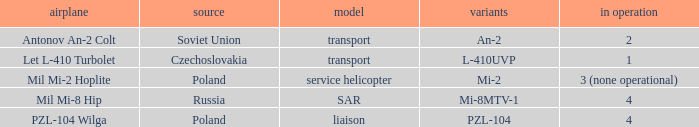Tell me the origin for mi-2 Poland. 